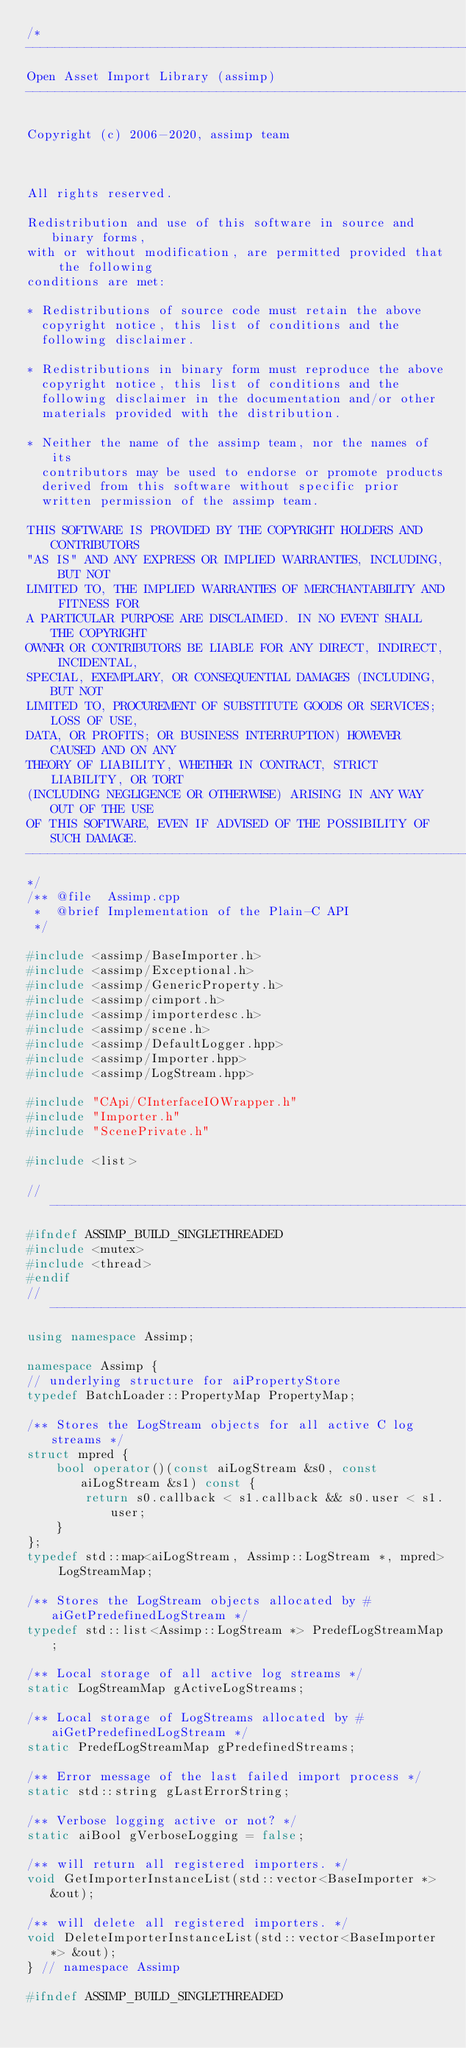<code> <loc_0><loc_0><loc_500><loc_500><_C++_>/*
---------------------------------------------------------------------------
Open Asset Import Library (assimp)
---------------------------------------------------------------------------

Copyright (c) 2006-2020, assimp team



All rights reserved.

Redistribution and use of this software in source and binary forms,
with or without modification, are permitted provided that the following
conditions are met:

* Redistributions of source code must retain the above
  copyright notice, this list of conditions and the
  following disclaimer.

* Redistributions in binary form must reproduce the above
  copyright notice, this list of conditions and the
  following disclaimer in the documentation and/or other
  materials provided with the distribution.

* Neither the name of the assimp team, nor the names of its
  contributors may be used to endorse or promote products
  derived from this software without specific prior
  written permission of the assimp team.

THIS SOFTWARE IS PROVIDED BY THE COPYRIGHT HOLDERS AND CONTRIBUTORS
"AS IS" AND ANY EXPRESS OR IMPLIED WARRANTIES, INCLUDING, BUT NOT
LIMITED TO, THE IMPLIED WARRANTIES OF MERCHANTABILITY AND FITNESS FOR
A PARTICULAR PURPOSE ARE DISCLAIMED. IN NO EVENT SHALL THE COPYRIGHT
OWNER OR CONTRIBUTORS BE LIABLE FOR ANY DIRECT, INDIRECT, INCIDENTAL,
SPECIAL, EXEMPLARY, OR CONSEQUENTIAL DAMAGES (INCLUDING, BUT NOT
LIMITED TO, PROCUREMENT OF SUBSTITUTE GOODS OR SERVICES; LOSS OF USE,
DATA, OR PROFITS; OR BUSINESS INTERRUPTION) HOWEVER CAUSED AND ON ANY
THEORY OF LIABILITY, WHETHER IN CONTRACT, STRICT LIABILITY, OR TORT
(INCLUDING NEGLIGENCE OR OTHERWISE) ARISING IN ANY WAY OUT OF THE USE
OF THIS SOFTWARE, EVEN IF ADVISED OF THE POSSIBILITY OF SUCH DAMAGE.
---------------------------------------------------------------------------
*/
/** @file  Assimp.cpp
 *  @brief Implementation of the Plain-C API
 */

#include <assimp/BaseImporter.h>
#include <assimp/Exceptional.h>
#include <assimp/GenericProperty.h>
#include <assimp/cimport.h>
#include <assimp/importerdesc.h>
#include <assimp/scene.h>
#include <assimp/DefaultLogger.hpp>
#include <assimp/Importer.hpp>
#include <assimp/LogStream.hpp>

#include "CApi/CInterfaceIOWrapper.h"
#include "Importer.h"
#include "ScenePrivate.h"

#include <list>

// ------------------------------------------------------------------------------------------------
#ifndef ASSIMP_BUILD_SINGLETHREADED
#include <mutex>
#include <thread>
#endif
// ------------------------------------------------------------------------------------------------
using namespace Assimp;

namespace Assimp {
// underlying structure for aiPropertyStore
typedef BatchLoader::PropertyMap PropertyMap;

/** Stores the LogStream objects for all active C log streams */
struct mpred {
    bool operator()(const aiLogStream &s0, const aiLogStream &s1) const {
        return s0.callback < s1.callback && s0.user < s1.user;
    }
};
typedef std::map<aiLogStream, Assimp::LogStream *, mpred> LogStreamMap;

/** Stores the LogStream objects allocated by #aiGetPredefinedLogStream */
typedef std::list<Assimp::LogStream *> PredefLogStreamMap;

/** Local storage of all active log streams */
static LogStreamMap gActiveLogStreams;

/** Local storage of LogStreams allocated by #aiGetPredefinedLogStream */
static PredefLogStreamMap gPredefinedStreams;

/** Error message of the last failed import process */
static std::string gLastErrorString;

/** Verbose logging active or not? */
static aiBool gVerboseLogging = false;

/** will return all registered importers. */
void GetImporterInstanceList(std::vector<BaseImporter *> &out);

/** will delete all registered importers. */
void DeleteImporterInstanceList(std::vector<BaseImporter *> &out);
} // namespace Assimp

#ifndef ASSIMP_BUILD_SINGLETHREADED</code> 